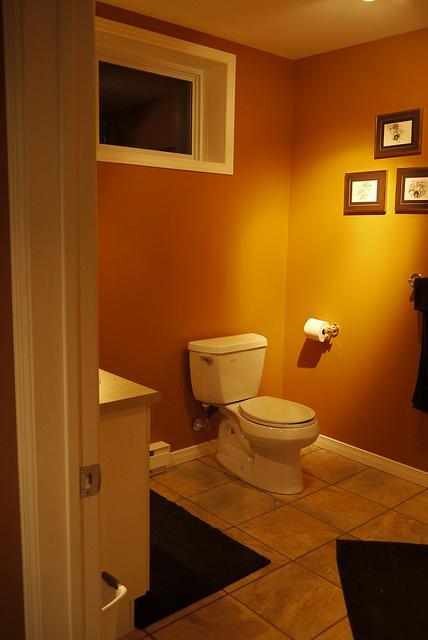Is the picture framed?
Concise answer only. Yes. What color is the wall?
Write a very short answer. Brown. Is this room in use?
Keep it brief. No. Is there a window above the toilet?
Short answer required. Yes. What is displayed in this room?
Be succinct. Toilet. What material is the door made from?
Keep it brief. Wood. Are the walls white?
Quick response, please. No. 